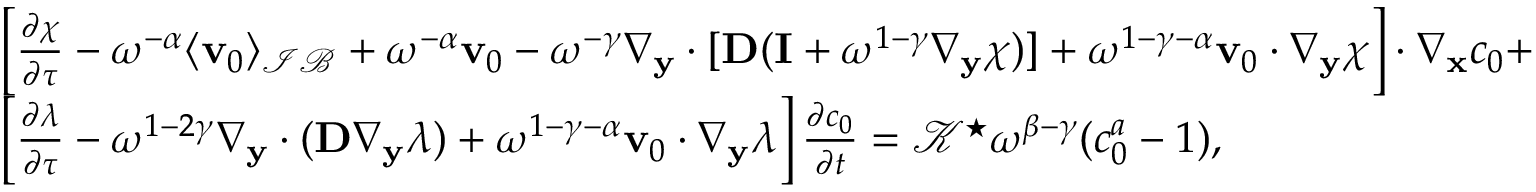<formula> <loc_0><loc_0><loc_500><loc_500>\begin{array} { r l } & { \left [ \frac { \partial \boldsymbol \chi } { \partial \tau } - \omega ^ { - \alpha } \langle \mathbf v _ { 0 } \rangle _ { \mathcal { I B } } + \omega ^ { - \alpha } \mathbf v _ { 0 } - \omega ^ { - \gamma } \nabla _ { \mathbf y } \cdot [ \mathbf D ( \mathbf I + \omega ^ { 1 - \gamma } \nabla _ { \mathbf y } \boldsymbol \chi ) ] + \omega ^ { 1 - \gamma - \alpha } \mathbf v _ { 0 } \cdot \nabla _ { \mathbf y } \boldsymbol \chi \right ] \cdot \nabla _ { \mathbf x } c _ { 0 } + } \\ & { \left [ \frac { \partial \lambda } { \partial \tau } - \omega ^ { 1 - 2 \gamma } \nabla _ { \mathbf y } \cdot ( \mathbf D \nabla _ { \mathbf y } \lambda ) + \omega ^ { 1 - \gamma - \alpha } \mathbf v _ { 0 } \cdot \nabla _ { \mathbf y } \lambda \right ] \frac { \partial c _ { 0 } } { \partial t } = \mathcal { K } ^ { ^ { * } } \omega ^ { \beta - \gamma } ( c _ { 0 } ^ { a } - 1 ) , } \end{array}</formula> 